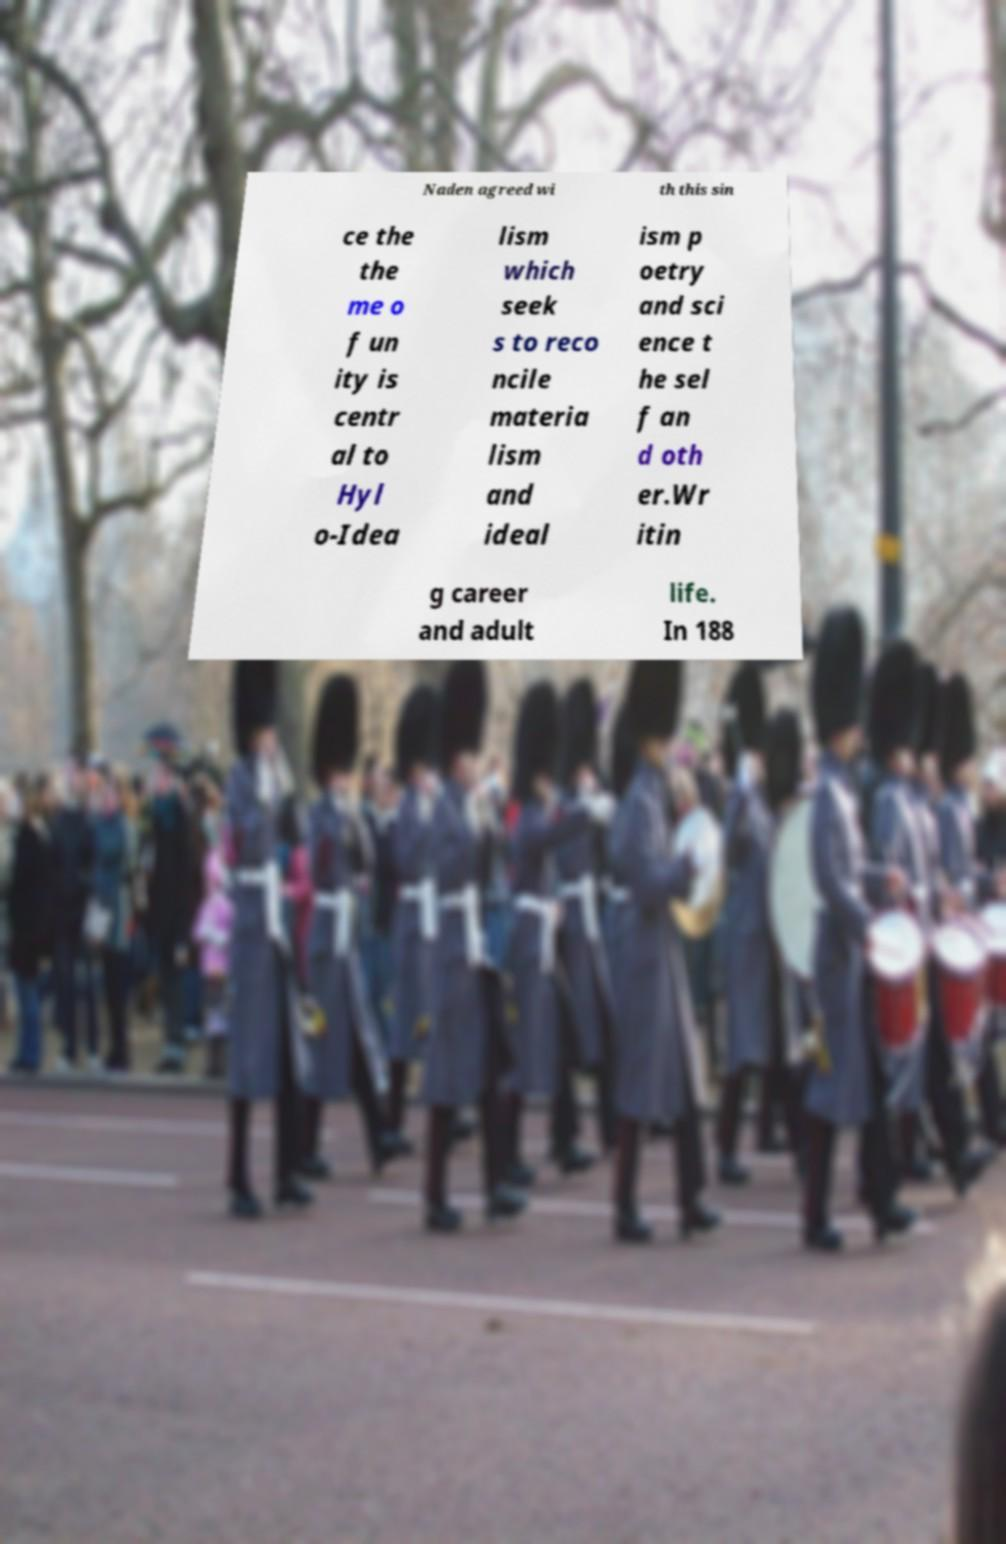Please identify and transcribe the text found in this image. Naden agreed wi th this sin ce the the me o f un ity is centr al to Hyl o-Idea lism which seek s to reco ncile materia lism and ideal ism p oetry and sci ence t he sel f an d oth er.Wr itin g career and adult life. In 188 